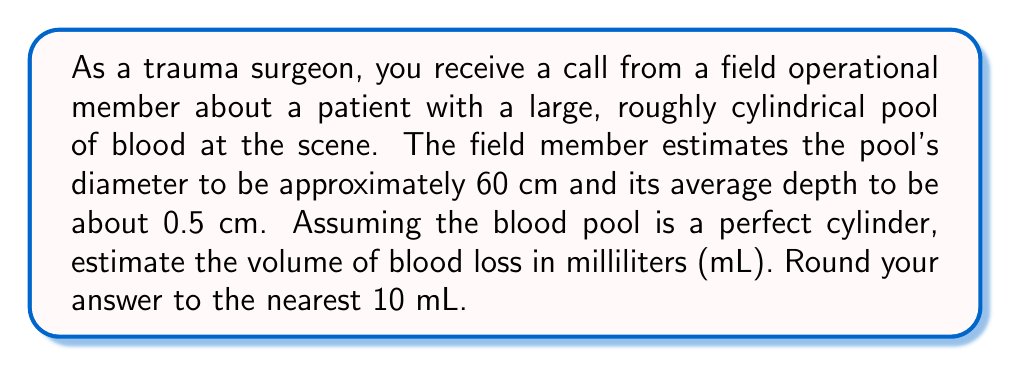Could you help me with this problem? To solve this problem, we need to follow these steps:

1) The volume of a cylinder is given by the formula:
   $$V = \pi r^2 h$$
   where $V$ is volume, $r$ is the radius of the base, and $h$ is the height (depth in this case).

2) We're given the diameter (60 cm), so we need to calculate the radius:
   $$r = \frac{diameter}{2} = \frac{60}{2} = 30 \text{ cm}$$

3) The depth (height) is given as 0.5 cm.

4) Now we can plug these values into our formula:
   $$V = \pi (30 \text{ cm})^2 (0.5 \text{ cm})$$

5) Simplify:
   $$V = \pi (900 \text{ cm}^2) (0.5 \text{ cm}) = 450\pi \text{ cm}^3$$

6) Calculate:
   $$V \approx 1413.72 \text{ cm}^3$$

7) Convert cubic centimeters to milliliters (1 cm³ = 1 mL):
   $$V \approx 1413.72 \text{ mL}$$

8) Round to the nearest 10 mL:
   $$V \approx 1410 \text{ mL}$$

This estimation method using geometric shapes allows for a quick assessment of blood loss volume in emergency situations.
Answer: Approximately 1410 mL 